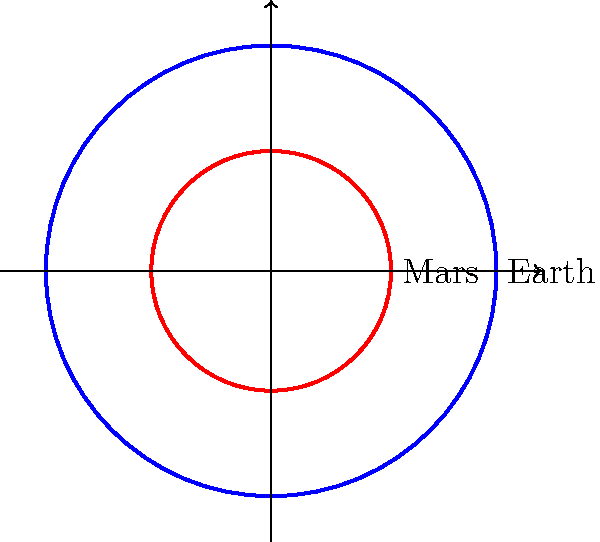The diagram shows the relative sizes of Earth and Mars. If the volume of Earth is approximately 1.08 × 10^12 km^3, what is the approximate volume of Mars? (Assume both planets are perfect spheres) To solve this problem, let's follow these steps:

1. Observe that the volume of a sphere is proportional to the cube of its radius: $V \propto r^3$

2. From the diagram, we can see that the radius of Mars (r_M) is 0.532 times the radius of Earth (r_E):
   $r_M = 0.532 r_E$

3. Let's set up a ratio of the volumes:
   $\frac{V_M}{V_E} = \left(\frac{r_M}{r_E}\right)^3$

4. Substitute the known ratio of radii:
   $\frac{V_M}{V_E} = (0.532)^3 = 0.151$

5. We know the volume of Earth ($V_E = 1.08 \times 10^{12}$ km^3), so:
   $V_M = 0.151 \times (1.08 \times 10^{12})$ km^3

6. Calculate:
   $V_M = 0.163 \times 10^{12}$ km^3

Therefore, the volume of Mars is approximately $1.63 \times 10^{11}$ km^3.
Answer: $1.63 \times 10^{11}$ km^3 